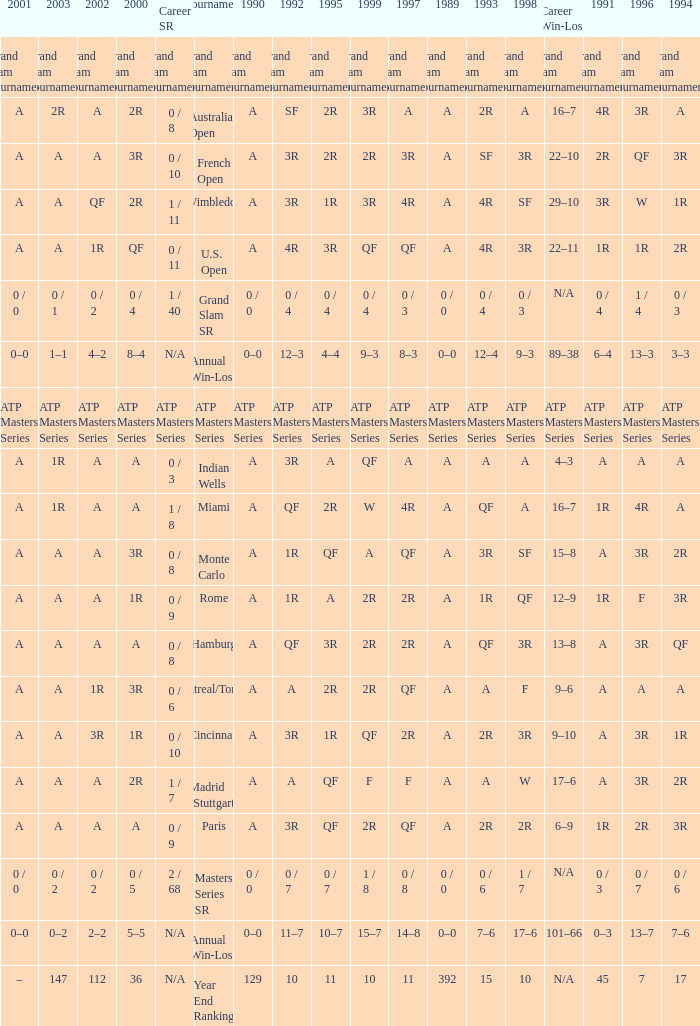Parse the full table. {'header': ['2001', '2003', '2002', '2000', 'Career SR', 'Tournament', '1990', '1992', '1995', '1999', '1997', '1989', '1993', '1998', 'Career Win-Loss', '1991', '1996', '1994'], 'rows': [['Grand Slam Tournaments', 'Grand Slam Tournaments', 'Grand Slam Tournaments', 'Grand Slam Tournaments', 'Grand Slam Tournaments', 'Grand Slam Tournaments', 'Grand Slam Tournaments', 'Grand Slam Tournaments', 'Grand Slam Tournaments', 'Grand Slam Tournaments', 'Grand Slam Tournaments', 'Grand Slam Tournaments', 'Grand Slam Tournaments', 'Grand Slam Tournaments', 'Grand Slam Tournaments', 'Grand Slam Tournaments', 'Grand Slam Tournaments', 'Grand Slam Tournaments'], ['A', '2R', 'A', '2R', '0 / 8', 'Australian Open', 'A', 'SF', '2R', '3R', 'A', 'A', '2R', 'A', '16–7', '4R', '3R', 'A'], ['A', 'A', 'A', '3R', '0 / 10', 'French Open', 'A', '3R', '2R', '2R', '3R', 'A', 'SF', '3R', '22–10', '2R', 'QF', '3R'], ['A', 'A', 'QF', '2R', '1 / 11', 'Wimbledon', 'A', '3R', '1R', '3R', '4R', 'A', '4R', 'SF', '29–10', '3R', 'W', '1R'], ['A', 'A', '1R', 'QF', '0 / 11', 'U.S. Open', 'A', '4R', '3R', 'QF', 'QF', 'A', '4R', '3R', '22–11', '1R', '1R', '2R'], ['0 / 0', '0 / 1', '0 / 2', '0 / 4', '1 / 40', 'Grand Slam SR', '0 / 0', '0 / 4', '0 / 4', '0 / 4', '0 / 3', '0 / 0', '0 / 4', '0 / 3', 'N/A', '0 / 4', '1 / 4', '0 / 3'], ['0–0', '1–1', '4–2', '8–4', 'N/A', 'Annual Win-Loss', '0–0', '12–3', '4–4', '9–3', '8–3', '0–0', '12–4', '9–3', '89–38', '6–4', '13–3', '3–3'], ['ATP Masters Series', 'ATP Masters Series', 'ATP Masters Series', 'ATP Masters Series', 'ATP Masters Series', 'ATP Masters Series', 'ATP Masters Series', 'ATP Masters Series', 'ATP Masters Series', 'ATP Masters Series', 'ATP Masters Series', 'ATP Masters Series', 'ATP Masters Series', 'ATP Masters Series', 'ATP Masters Series', 'ATP Masters Series', 'ATP Masters Series', 'ATP Masters Series'], ['A', '1R', 'A', 'A', '0 / 3', 'Indian Wells', 'A', '3R', 'A', 'QF', 'A', 'A', 'A', 'A', '4–3', 'A', 'A', 'A'], ['A', '1R', 'A', 'A', '1 / 8', 'Miami', 'A', 'QF', '2R', 'W', '4R', 'A', 'QF', 'A', '16–7', '1R', '4R', 'A'], ['A', 'A', 'A', '3R', '0 / 8', 'Monte Carlo', 'A', '1R', 'QF', 'A', 'QF', 'A', '3R', 'SF', '15–8', 'A', '3R', '2R'], ['A', 'A', 'A', '1R', '0 / 9', 'Rome', 'A', '1R', 'A', '2R', '2R', 'A', '1R', 'QF', '12–9', '1R', 'F', '3R'], ['A', 'A', 'A', 'A', '0 / 8', 'Hamburg', 'A', 'QF', '3R', '2R', '2R', 'A', 'QF', '3R', '13–8', 'A', '3R', 'QF'], ['A', 'A', '1R', '3R', '0 / 6', 'Montreal/Toronto', 'A', 'A', '2R', '2R', 'QF', 'A', 'A', 'F', '9–6', 'A', 'A', 'A'], ['A', 'A', '3R', '1R', '0 / 10', 'Cincinnati', 'A', '3R', '1R', 'QF', '2R', 'A', '2R', '3R', '9–10', 'A', '3R', '1R'], ['A', 'A', 'A', '2R', '1 / 7', 'Madrid (Stuttgart)', 'A', 'A', 'QF', 'F', 'F', 'A', 'A', 'W', '17–6', 'A', '3R', '2R'], ['A', 'A', 'A', 'A', '0 / 9', 'Paris', 'A', '3R', 'QF', '2R', 'QF', 'A', '2R', '2R', '6–9', '1R', '2R', '3R'], ['0 / 0', '0 / 2', '0 / 2', '0 / 5', '2 / 68', 'Masters Series SR', '0 / 0', '0 / 7', '0 / 7', '1 / 8', '0 / 8', '0 / 0', '0 / 6', '1 / 7', 'N/A', '0 / 3', '0 / 7', '0 / 6'], ['0–0', '0–2', '2–2', '5–5', 'N/A', 'Annual Win-Loss', '0–0', '11–7', '10–7', '15–7', '14–8', '0–0', '7–6', '17–6', '101–66', '0–3', '13–7', '7–6'], ['–', '147', '112', '36', 'N/A', 'Year End Ranking', '129', '10', '11', '10', '11', '392', '15', '10', 'N/A', '45', '7', '17']]} What was the amount in 1989 with qf in 1997 and a in 1993? A. 